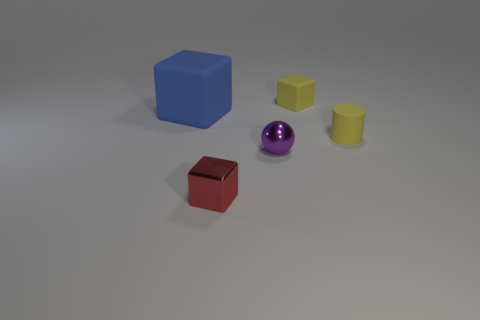If these objects were real, what could be their potential use? Considering their shapes and sizes, if these objects were real, they could be children's building blocks, elements for a tabletop game, or educational tools for learning shapes and colors. 